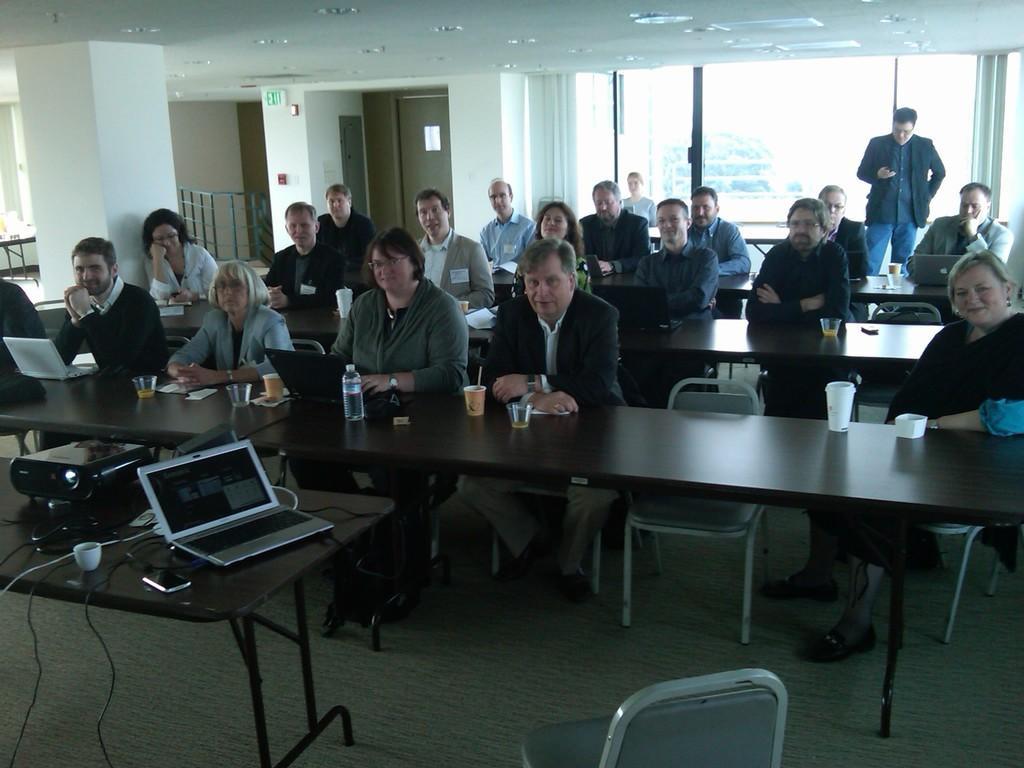Please provide a concise description of this image. In this image we can see this people are sitting on the chairs near the tables. There are laptops, glasses, tins, projector, water bottle and cup on the table. In the background we can see glass windows. 